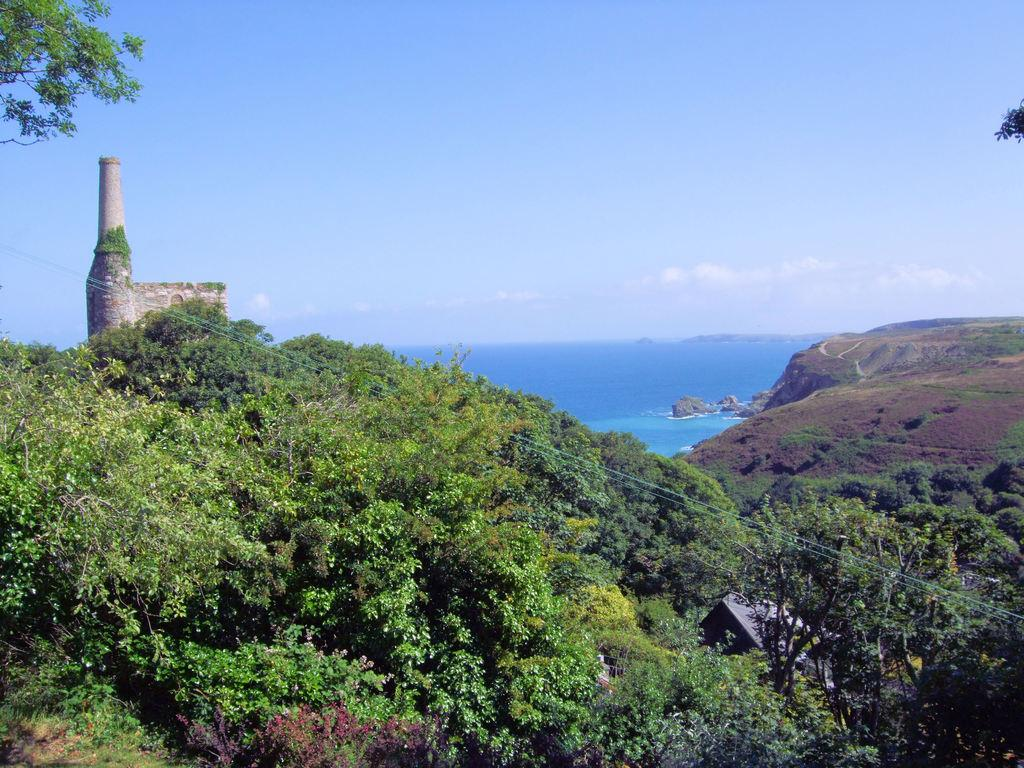What type of vegetation can be seen in the image? There are trees in the image. What type of infrastructure is present in the image? Cables, a tower, a house, and a wall are visible in the image. What type of natural landscape can be seen in the image? Hills are visible in the image. What type of water body is present in the image? The sea is visible in the image. What type of material is present in the image? Stones are present in the image. What type of liquid is visible in the image? Water is visible in the image. What type of atmospheric conditions can be seen in the image? The sky and clouds are visible in the image. What type of paste is being used to create the smoke in the image? There is no paste or smoke present in the image. What type of camera is being used to capture the image? The type of camera used to capture the image is not visible or mentioned in the image. 